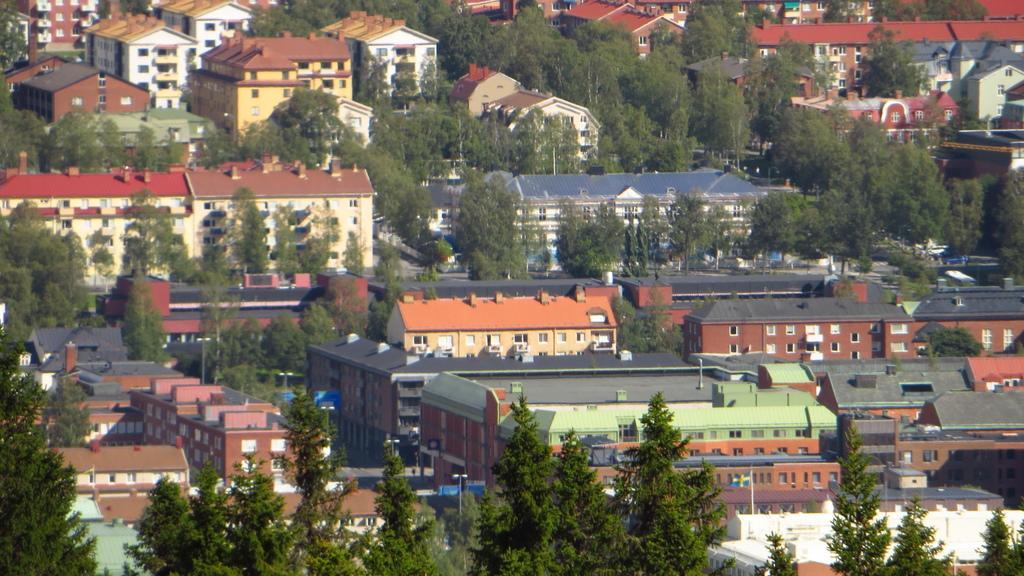Please provide a concise description of this image. In the image I can see the view of a place where we have some buildings, houses and also I can see some trees and plants. 